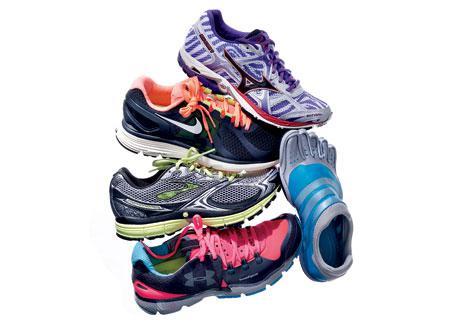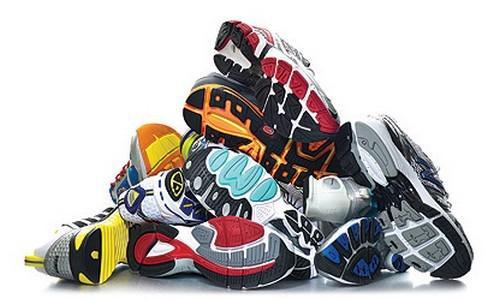The first image is the image on the left, the second image is the image on the right. Given the left and right images, does the statement "There is a triangular pile of shoes in the image on the right." hold true? Answer yes or no. Yes. 